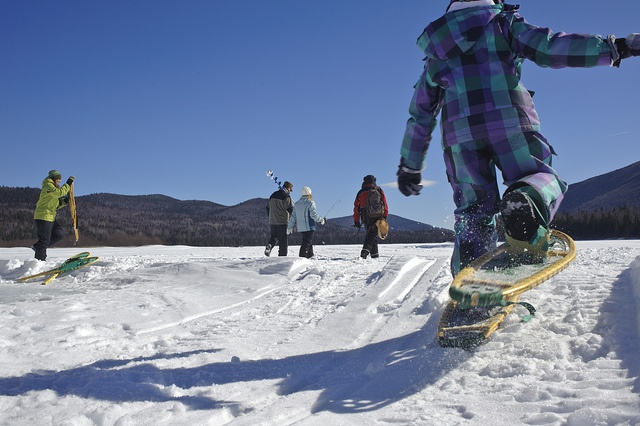Describe the objects in this image and their specific colors. I can see people in blue, navy, black, and gray tones, snowboard in blue, darkgray, gray, tan, and black tones, people in blue, black, darkgreen, olive, and gray tones, people in blue, black, maroon, and gray tones, and people in blue, black, gray, and darkgray tones in this image. 